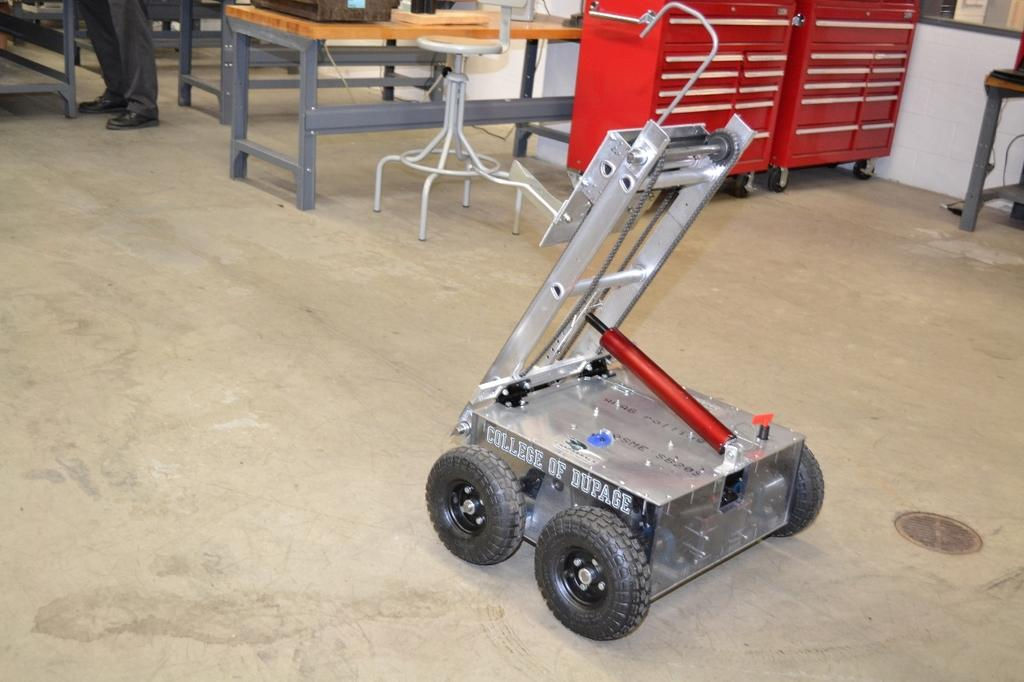What type of space is shown in the image? The image depicts a room. What can be found on the floor of the room? There is a vehicle on the floor. What furniture is present in the room? There are tables in the room. Can you describe any part of a person in the image? A person's legs are visible in the image. What type of seating is available in the room? There is a chair in the room. What color is the kite that is being flown in the room? There is no kite present in the image, so it cannot be determined what color it might be. 